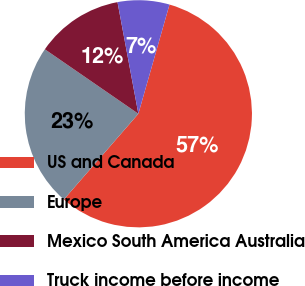Convert chart. <chart><loc_0><loc_0><loc_500><loc_500><pie_chart><fcel>US and Canada<fcel>Europe<fcel>Mexico South America Australia<fcel>Truck income before income<nl><fcel>56.97%<fcel>23.22%<fcel>12.45%<fcel>7.36%<nl></chart> 